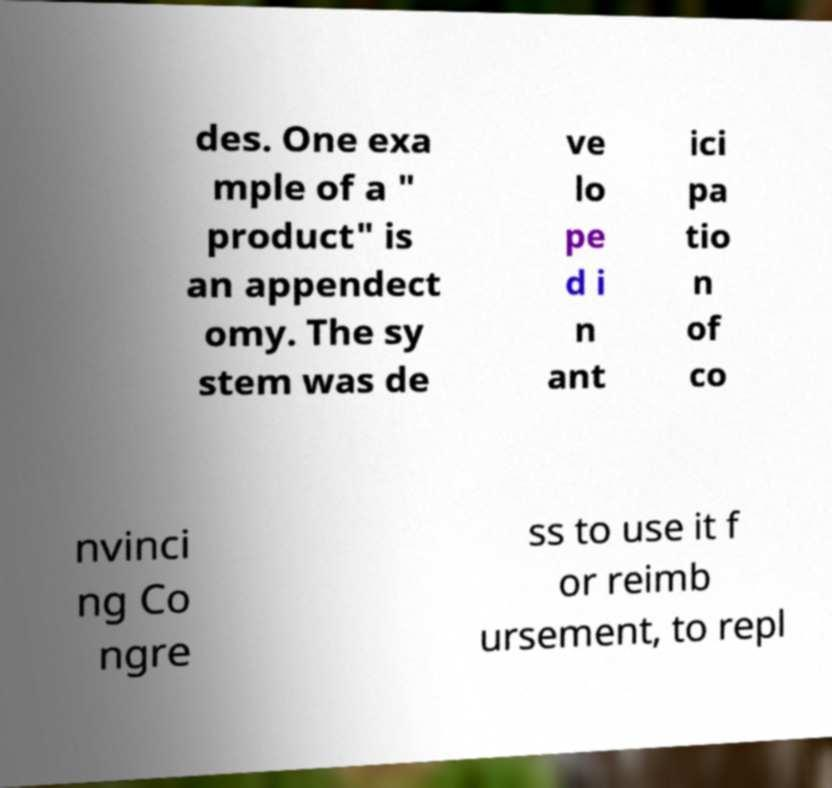There's text embedded in this image that I need extracted. Can you transcribe it verbatim? des. One exa mple of a " product" is an appendect omy. The sy stem was de ve lo pe d i n ant ici pa tio n of co nvinci ng Co ngre ss to use it f or reimb ursement, to repl 